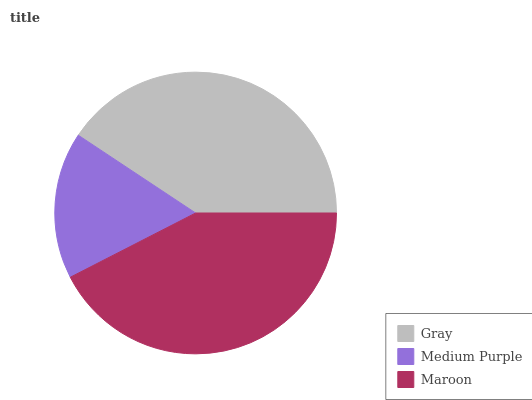Is Medium Purple the minimum?
Answer yes or no. Yes. Is Maroon the maximum?
Answer yes or no. Yes. Is Maroon the minimum?
Answer yes or no. No. Is Medium Purple the maximum?
Answer yes or no. No. Is Maroon greater than Medium Purple?
Answer yes or no. Yes. Is Medium Purple less than Maroon?
Answer yes or no. Yes. Is Medium Purple greater than Maroon?
Answer yes or no. No. Is Maroon less than Medium Purple?
Answer yes or no. No. Is Gray the high median?
Answer yes or no. Yes. Is Gray the low median?
Answer yes or no. Yes. Is Medium Purple the high median?
Answer yes or no. No. Is Maroon the low median?
Answer yes or no. No. 